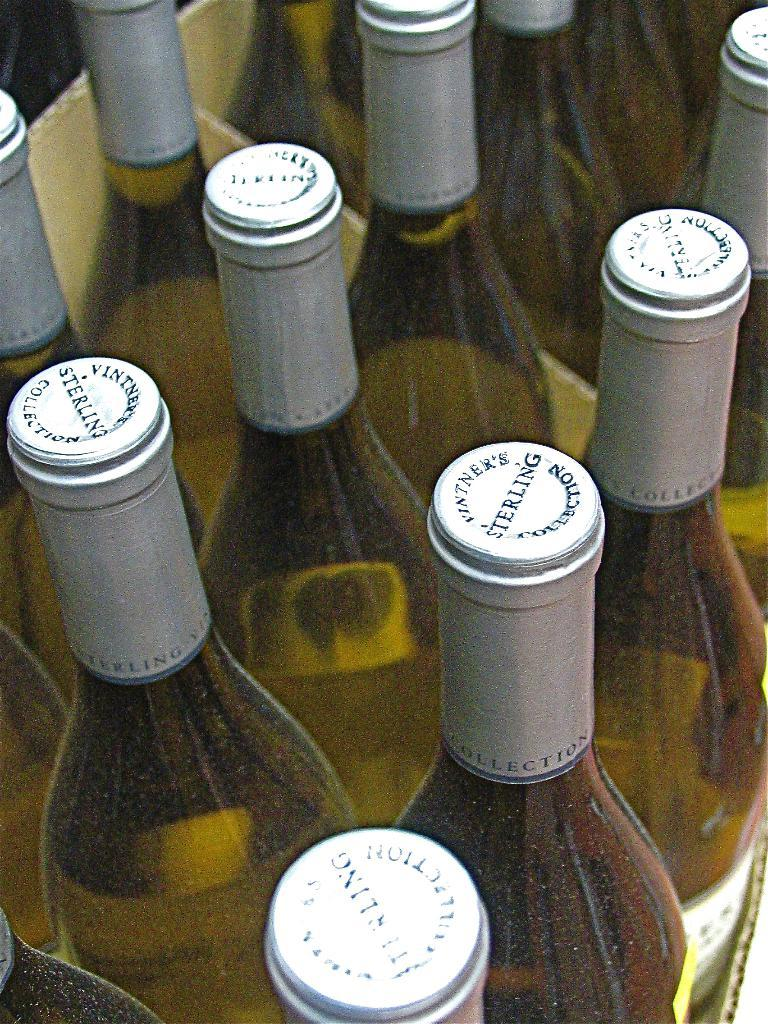What objects are present in the image? There are bottles in the image. How are the bottles arranged or organized? The bottles are arranged in a carton box. Can you see any boats in the image? No, there are no boats present in the image. What type of place is depicted in the image? The image does not depict a specific place; it only shows bottles arranged in a carton box. 